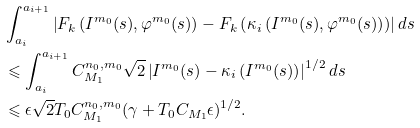Convert formula to latex. <formula><loc_0><loc_0><loc_500><loc_500>& \int _ { a _ { i } } ^ { a _ { i + 1 } } \left | F _ { k } \left ( I ^ { m _ { 0 } } ( s ) , \varphi ^ { m _ { 0 } } ( s ) \right ) - F _ { k } \left ( \kappa _ { i } \left ( I ^ { m _ { 0 } } ( s ) , \varphi ^ { m _ { 0 } } ( s ) \right ) \right ) \right | d s \\ & \leqslant \int _ { a _ { i } } ^ { a _ { i + 1 } } C ^ { n _ { 0 } , m _ { 0 } } _ { M _ { 1 } } \sqrt { 2 } \left | I ^ { m _ { 0 } } ( s ) - \kappa _ { i } \left ( I ^ { m _ { 0 } } ( s ) \right ) \right | ^ { 1 / 2 } d s \\ & \leqslant \epsilon \sqrt { 2 } T _ { 0 } C _ { M _ { 1 } } ^ { n _ { 0 } , m _ { 0 } } ( \gamma + T _ { 0 } C _ { M _ { 1 } } \epsilon ) ^ { 1 / 2 } .</formula> 